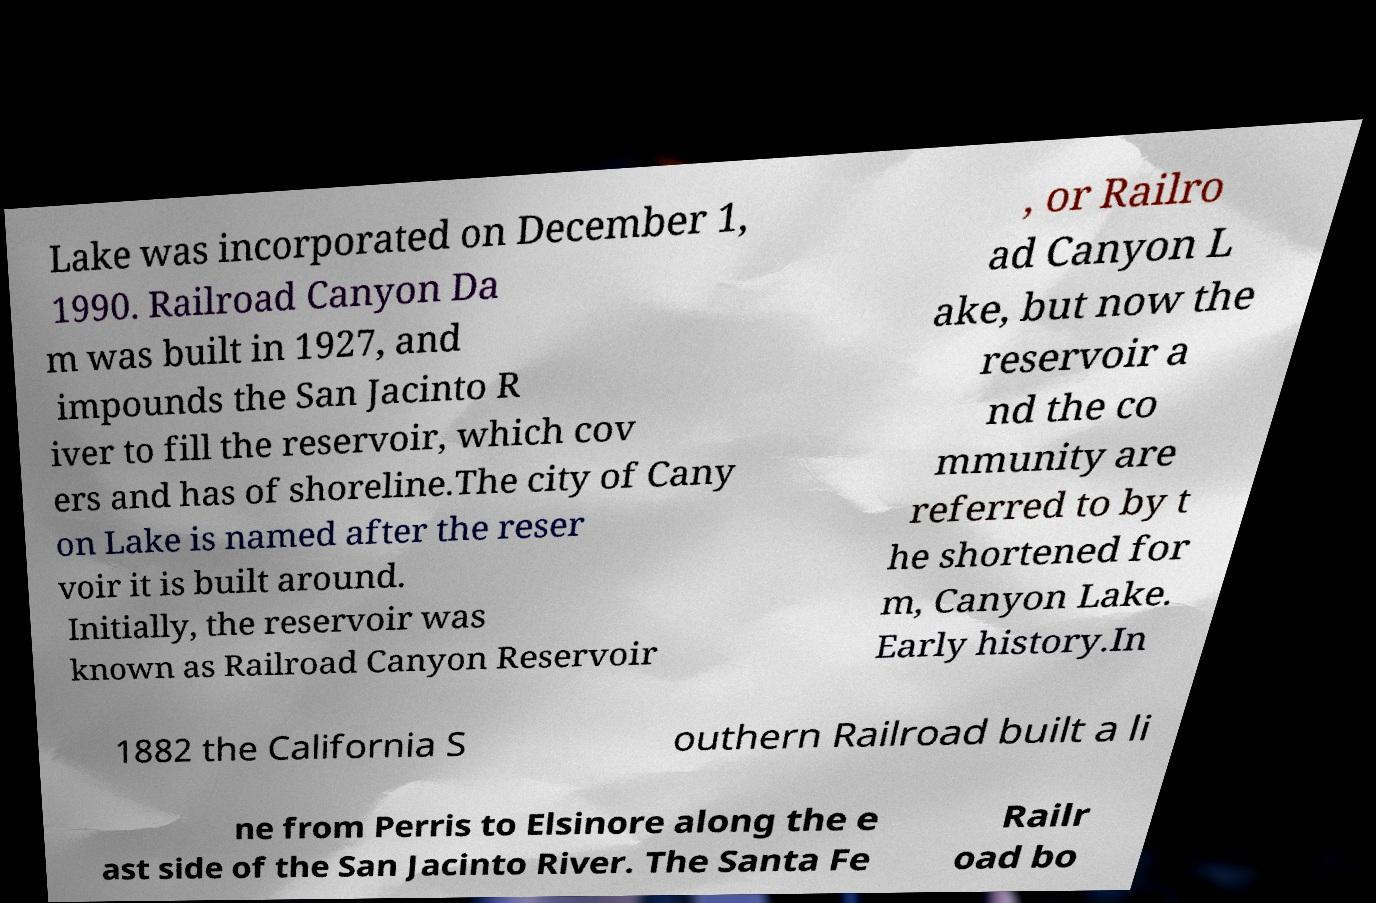For documentation purposes, I need the text within this image transcribed. Could you provide that? Lake was incorporated on December 1, 1990. Railroad Canyon Da m was built in 1927, and impounds the San Jacinto R iver to fill the reservoir, which cov ers and has of shoreline.The city of Cany on Lake is named after the reser voir it is built around. Initially, the reservoir was known as Railroad Canyon Reservoir , or Railro ad Canyon L ake, but now the reservoir a nd the co mmunity are referred to by t he shortened for m, Canyon Lake. Early history.In 1882 the California S outhern Railroad built a li ne from Perris to Elsinore along the e ast side of the San Jacinto River. The Santa Fe Railr oad bo 